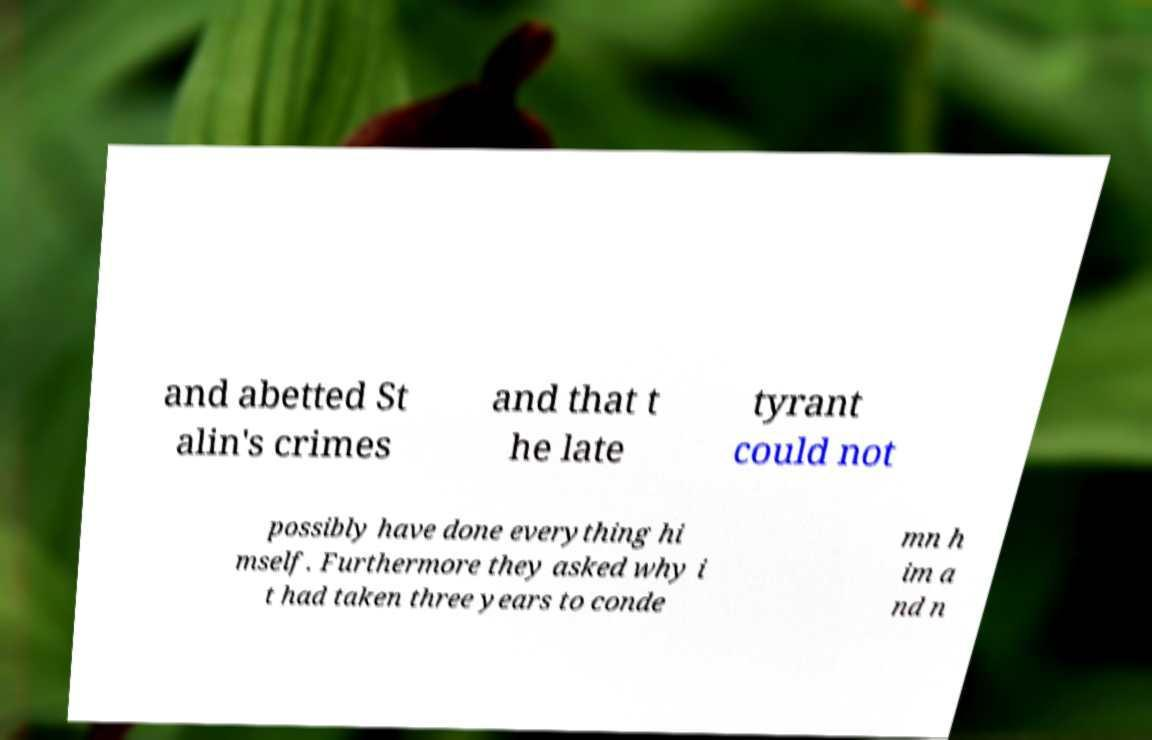I need the written content from this picture converted into text. Can you do that? and abetted St alin's crimes and that t he late tyrant could not possibly have done everything hi mself. Furthermore they asked why i t had taken three years to conde mn h im a nd n 